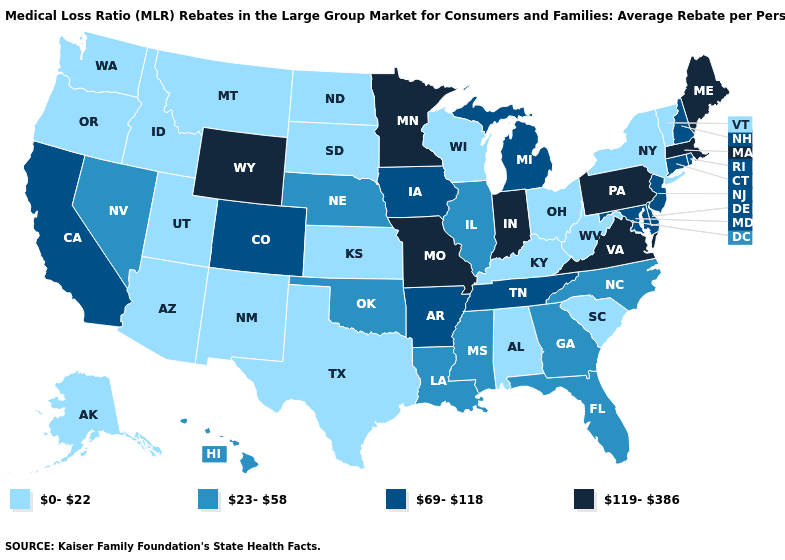What is the value of Massachusetts?
Keep it brief. 119-386. What is the value of Minnesota?
Give a very brief answer. 119-386. What is the highest value in the MidWest ?
Give a very brief answer. 119-386. What is the value of North Dakota?
Write a very short answer. 0-22. Does Minnesota have the highest value in the USA?
Short answer required. Yes. Name the states that have a value in the range 23-58?
Concise answer only. Florida, Georgia, Hawaii, Illinois, Louisiana, Mississippi, Nebraska, Nevada, North Carolina, Oklahoma. What is the highest value in the MidWest ?
Be succinct. 119-386. What is the value of Kentucky?
Quick response, please. 0-22. What is the lowest value in the USA?
Concise answer only. 0-22. Name the states that have a value in the range 0-22?
Concise answer only. Alabama, Alaska, Arizona, Idaho, Kansas, Kentucky, Montana, New Mexico, New York, North Dakota, Ohio, Oregon, South Carolina, South Dakota, Texas, Utah, Vermont, Washington, West Virginia, Wisconsin. Does Nevada have the lowest value in the West?
Quick response, please. No. Name the states that have a value in the range 119-386?
Quick response, please. Indiana, Maine, Massachusetts, Minnesota, Missouri, Pennsylvania, Virginia, Wyoming. Which states have the lowest value in the USA?
Quick response, please. Alabama, Alaska, Arizona, Idaho, Kansas, Kentucky, Montana, New Mexico, New York, North Dakota, Ohio, Oregon, South Carolina, South Dakota, Texas, Utah, Vermont, Washington, West Virginia, Wisconsin. Does Wyoming have the lowest value in the West?
Answer briefly. No. Does Maine have the highest value in the Northeast?
Concise answer only. Yes. 